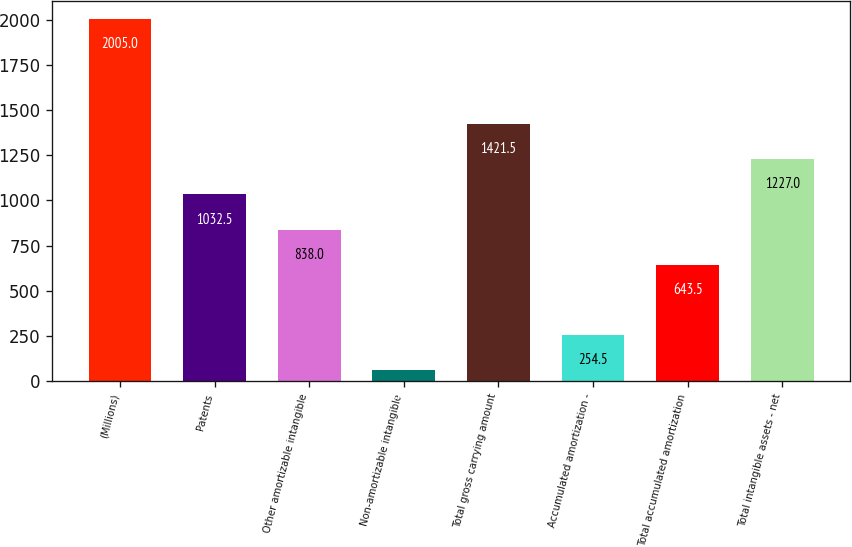Convert chart to OTSL. <chart><loc_0><loc_0><loc_500><loc_500><bar_chart><fcel>(Millions)<fcel>Patents<fcel>Other amortizable intangible<fcel>Non-amortizable intangible<fcel>Total gross carrying amount<fcel>Accumulated amortization -<fcel>Total accumulated amortization<fcel>Total intangible assets - net<nl><fcel>2005<fcel>1032.5<fcel>838<fcel>60<fcel>1421.5<fcel>254.5<fcel>643.5<fcel>1227<nl></chart> 